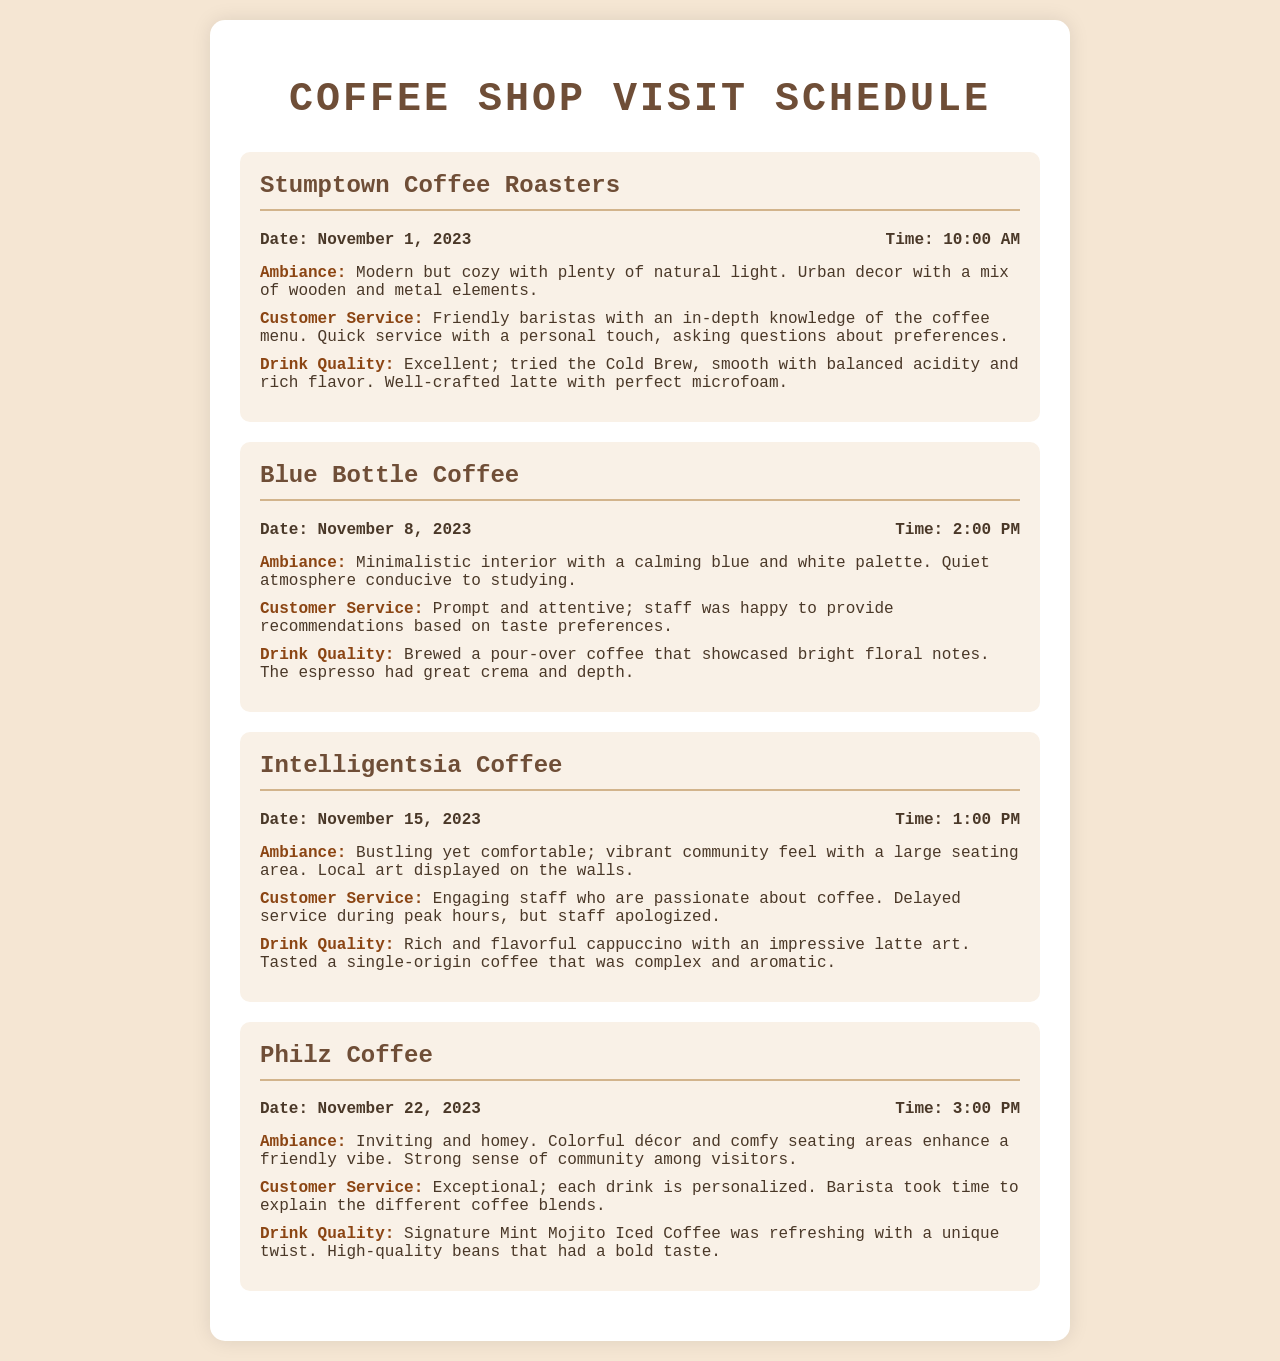What is the name of the first coffee shop visited? The document lists Stumptown Coffee Roasters as the first coffee shop visited on November 1, 2023.
Answer: Stumptown Coffee Roasters What was the drink tried at Blue Bottle Coffee? The document indicates that a pour-over coffee showcasing bright floral notes was brewed during the visit to Blue Bottle Coffee.
Answer: Pour-over coffee What is the ambiance description of Philz Coffee? Philz Coffee is described as inviting and homey, with colorful décor and comfy seating areas enhancing a friendly vibe.
Answer: Inviting and homey How many coffee shops are included in the schedule? The document includes a total of four coffee shops in the visit schedule.
Answer: Four What time was the visit to Intelligentsia Coffee? The document states that the visit to Intelligentsia Coffee occurred at 1:00 PM on November 15, 2023.
Answer: 1:00 PM Which coffee shop is noted for having friendly baristas? Stumptown Coffee Roasters is recognized for having friendly baristas with in-depth knowledge of the coffee menu.
Answer: Stumptown Coffee Roasters What unique drink was mentioned for Philz Coffee? The document highlights the Signature Mint Mojito Iced Coffee as a refreshing drink with a unique twist that was served at Philz Coffee.
Answer: Mint Mojito Iced Coffee What was the customer service experience at Intelligentsia Coffee? The customer service was characterized by engaging staff who are passionate about coffee, despite delays during peak hours.
Answer: Engaging staff What type of coffee did Blue Bottle Coffee serve? The document specifies that Blue Bottle Coffee served espresso with great crema and depth.
Answer: Espresso 